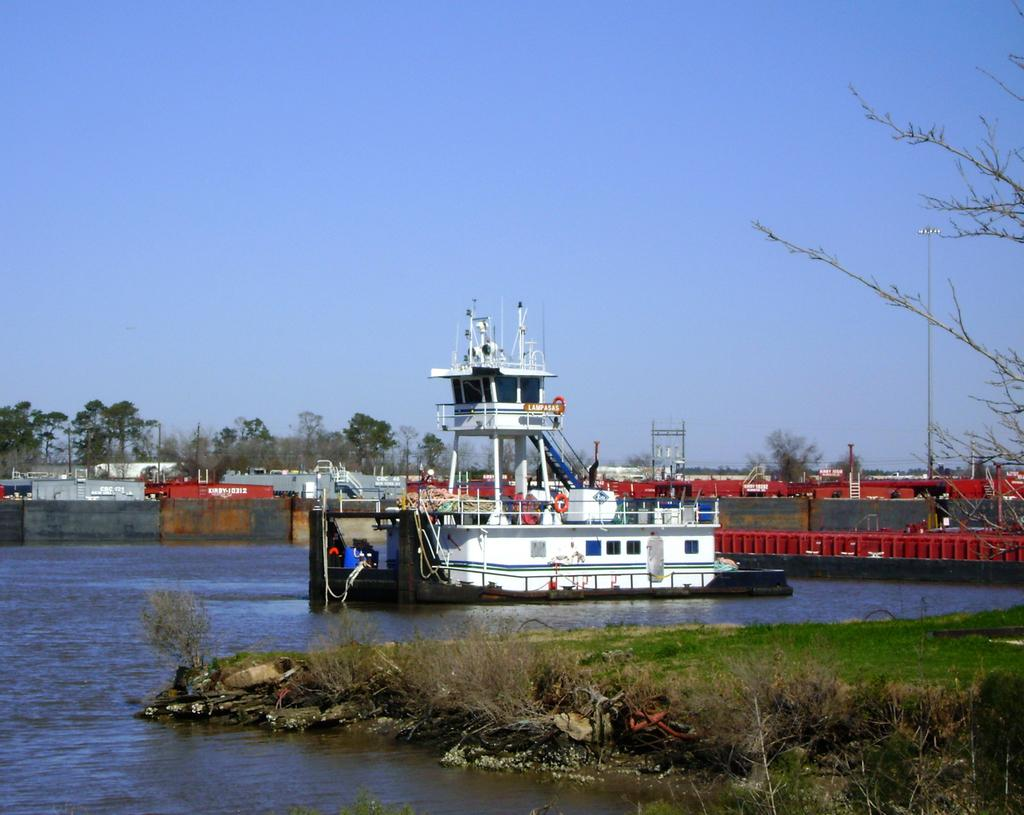What is the main subject in the center of the image? There is a ship in the center of the image. Where is the ship located? The ship is on the water. What type of vegetation and ground cover can be seen on the right side of the image? There is a tree and grass on the right side of the image. What can be seen in the background of the image? There are containers, trees, a pole, and the sky visible in the background of the image. What is the tendency of the police to serve the ship in the image? There is no police or servant present in the image, so it is not possible to determine any tendencies related to serving the ship. 